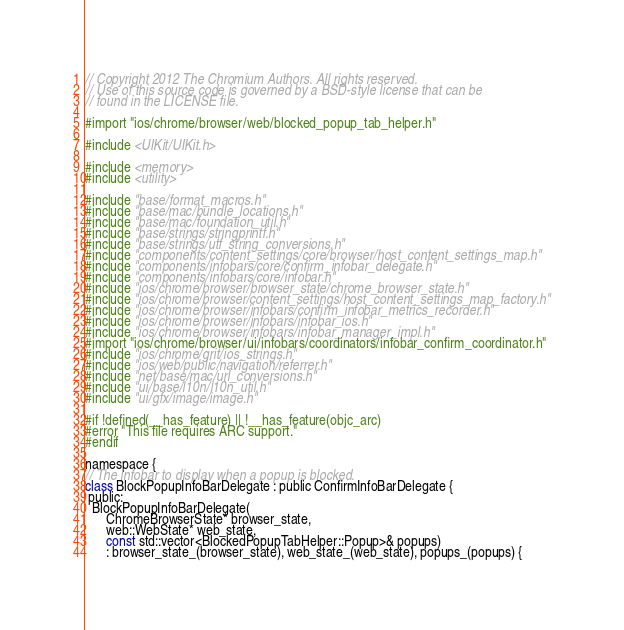Convert code to text. <code><loc_0><loc_0><loc_500><loc_500><_ObjectiveC_>// Copyright 2012 The Chromium Authors. All rights reserved.
// Use of this source code is governed by a BSD-style license that can be
// found in the LICENSE file.

#import "ios/chrome/browser/web/blocked_popup_tab_helper.h"

#include <UIKit/UIKit.h>

#include <memory>
#include <utility>

#include "base/format_macros.h"
#include "base/mac/bundle_locations.h"
#include "base/mac/foundation_util.h"
#include "base/strings/stringprintf.h"
#include "base/strings/utf_string_conversions.h"
#include "components/content_settings/core/browser/host_content_settings_map.h"
#include "components/infobars/core/confirm_infobar_delegate.h"
#include "components/infobars/core/infobar.h"
#include "ios/chrome/browser/browser_state/chrome_browser_state.h"
#include "ios/chrome/browser/content_settings/host_content_settings_map_factory.h"
#include "ios/chrome/browser/infobars/confirm_infobar_metrics_recorder.h"
#include "ios/chrome/browser/infobars/infobar_ios.h"
#include "ios/chrome/browser/infobars/infobar_manager_impl.h"
#import "ios/chrome/browser/ui/infobars/coordinators/infobar_confirm_coordinator.h"
#include "ios/chrome/grit/ios_strings.h"
#include "ios/web/public/navigation/referrer.h"
#include "net/base/mac/url_conversions.h"
#include "ui/base/l10n/l10n_util.h"
#include "ui/gfx/image/image.h"

#if !defined(__has_feature) || !__has_feature(objc_arc)
#error "This file requires ARC support."
#endif

namespace {
// The infobar to display when a popup is blocked.
class BlockPopupInfoBarDelegate : public ConfirmInfoBarDelegate {
 public:
  BlockPopupInfoBarDelegate(
      ChromeBrowserState* browser_state,
      web::WebState* web_state,
      const std::vector<BlockedPopupTabHelper::Popup>& popups)
      : browser_state_(browser_state), web_state_(web_state), popups_(popups) {</code> 